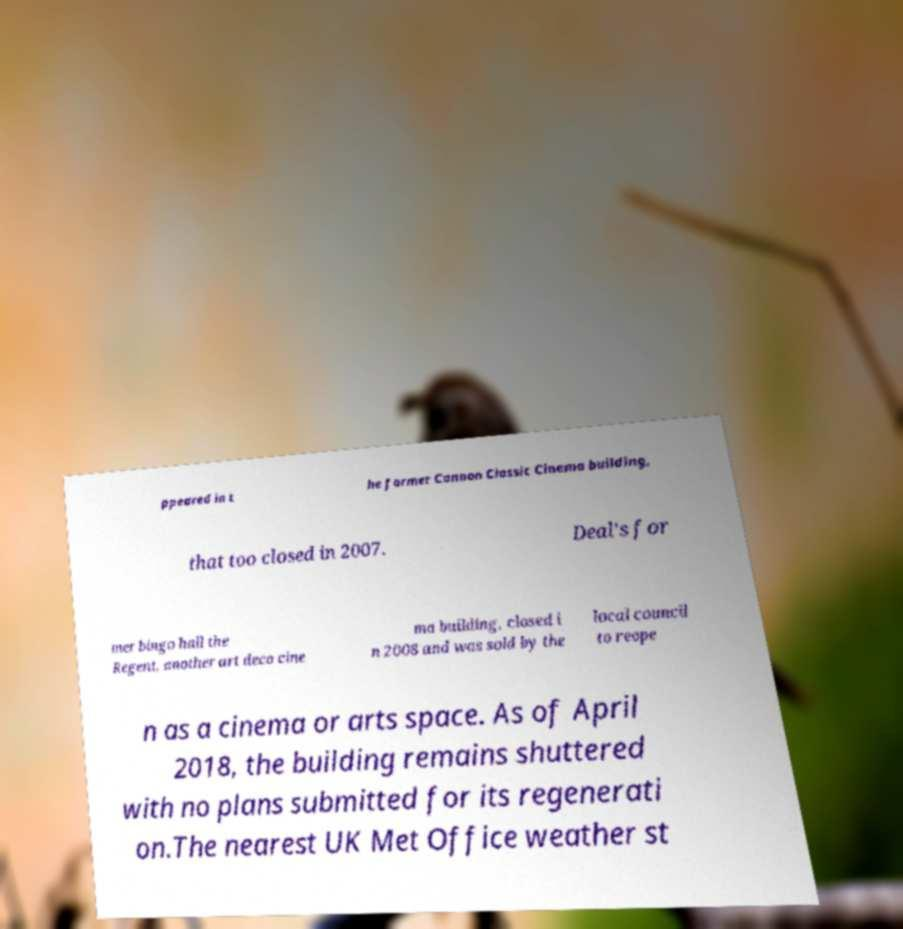For documentation purposes, I need the text within this image transcribed. Could you provide that? ppeared in t he former Cannon Classic Cinema building, that too closed in 2007. Deal's for mer bingo hall the Regent, another art deco cine ma building, closed i n 2008 and was sold by the local council to reope n as a cinema or arts space. As of April 2018, the building remains shuttered with no plans submitted for its regenerati on.The nearest UK Met Office weather st 